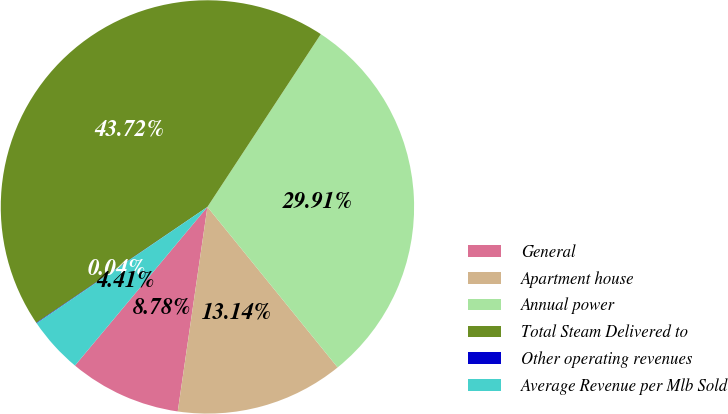<chart> <loc_0><loc_0><loc_500><loc_500><pie_chart><fcel>General<fcel>Apartment house<fcel>Annual power<fcel>Total Steam Delivered to<fcel>Other operating revenues<fcel>Average Revenue per Mlb Sold<nl><fcel>8.78%<fcel>13.14%<fcel>29.91%<fcel>43.72%<fcel>0.04%<fcel>4.41%<nl></chart> 